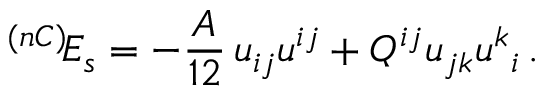<formula> <loc_0><loc_0><loc_500><loc_500>^ { ( n C ) } \, E _ { s } = - \frac { A } { 1 2 } \, u _ { i j } u ^ { i j } + Q ^ { i j } u _ { j k } u ^ { k _ { i } \, .</formula> 